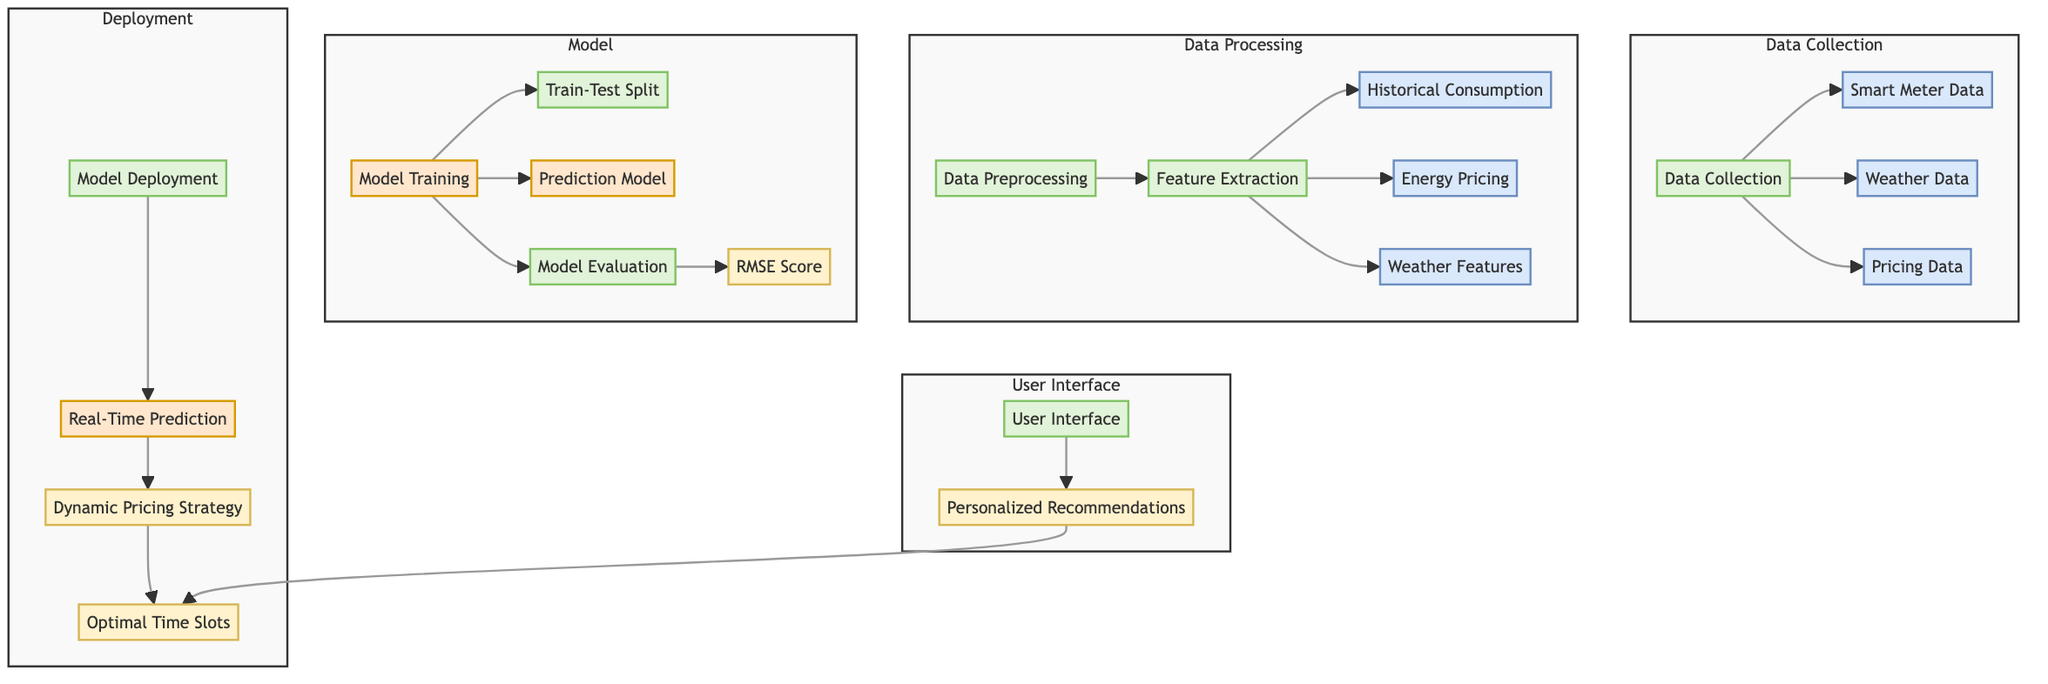What are the components of the data collection? The data collection consists of three components: Smart Meter Data, Weather Data, and Pricing Data. These are the data sources identified in the diagram under the Data Collection section.
Answer: Smart Meter Data, Weather Data, Pricing Data How many nodes are present in the Model section? The Model section contains four nodes: Model Training, Train-Test Split, Prediction Model, and Model Evaluation. Counting these nodes provides the total number of nodes in this section.
Answer: 4 What is the output of the Model Evaluation? The output of the Model Evaluation is the RMSE Score. The diagram indicates this as the final output for the model evaluation process.
Answer: RMSE Score What comes after Data Preprocessing in the flow? After Data Preprocessing, the next step in the flow is Feature Extraction, which is the subsequent process indicated in the diagram.
Answer: Feature Extraction What is the purpose of the User Interface in the diagram? The purpose of the User Interface is to provide Personalized Recommendations, as indicated by the output node connected to the User Interface process.
Answer: Personalized Recommendations How many data sources feed into Data Preprocessing? There are three data sources that feed into Data Preprocessing: Historical Consumption, Energy Pricing, and Weather Features. They all branch out from Feature Extraction according to the diagram.
Answer: 3 What is the relationship between Real-Time Prediction and Dynamic Pricing Strategy? Real-Time Prediction produces the Dynamic Pricing Strategy as an output, showing that the prediction model influences the pricing strategy directly.
Answer: Influential output What processes are included in the Deployment section? The Deployment section includes two processes: Model Deployment and Real-Time Prediction, indicating the flow of the model into real-time application.
Answer: Model Deployment, Real-Time Prediction Which step follows Model Training based on the diagram's flow? After Model Training, the step that follows is Train-Test Split, which is critical for evaluating the model's performance as indicated in the diagram.
Answer: Train-Test Split 